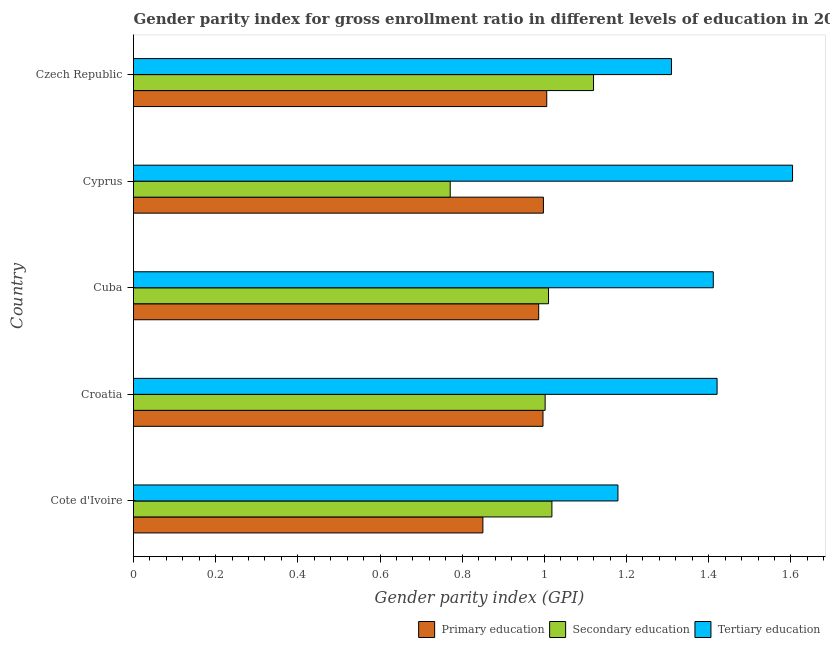How many different coloured bars are there?
Your answer should be compact. 3. Are the number of bars per tick equal to the number of legend labels?
Provide a succinct answer. Yes. How many bars are there on the 2nd tick from the top?
Your answer should be compact. 3. What is the label of the 1st group of bars from the top?
Give a very brief answer. Czech Republic. In how many cases, is the number of bars for a given country not equal to the number of legend labels?
Your response must be concise. 0. What is the gender parity index in secondary education in Croatia?
Offer a very short reply. 1. Across all countries, what is the maximum gender parity index in secondary education?
Offer a very short reply. 1.12. Across all countries, what is the minimum gender parity index in primary education?
Your answer should be very brief. 0.85. In which country was the gender parity index in tertiary education maximum?
Your answer should be very brief. Cyprus. In which country was the gender parity index in secondary education minimum?
Ensure brevity in your answer.  Cyprus. What is the total gender parity index in tertiary education in the graph?
Offer a terse response. 6.92. What is the difference between the gender parity index in primary education in Cuba and that in Czech Republic?
Provide a succinct answer. -0.02. What is the difference between the gender parity index in tertiary education in Cyprus and the gender parity index in primary education in Cuba?
Keep it short and to the point. 0.62. What is the average gender parity index in tertiary education per country?
Provide a succinct answer. 1.39. What is the difference between the gender parity index in secondary education and gender parity index in tertiary education in Cote d'Ivoire?
Provide a short and direct response. -0.16. What is the ratio of the gender parity index in tertiary education in Croatia to that in Czech Republic?
Offer a very short reply. 1.08. Is the gender parity index in secondary education in Cote d'Ivoire less than that in Cuba?
Offer a very short reply. No. Is the difference between the gender parity index in secondary education in Cote d'Ivoire and Croatia greater than the difference between the gender parity index in primary education in Cote d'Ivoire and Croatia?
Ensure brevity in your answer.  Yes. What is the difference between the highest and the second highest gender parity index in secondary education?
Your response must be concise. 0.1. What is the difference between the highest and the lowest gender parity index in primary education?
Give a very brief answer. 0.16. In how many countries, is the gender parity index in tertiary education greater than the average gender parity index in tertiary education taken over all countries?
Your response must be concise. 3. What does the 2nd bar from the top in Cuba represents?
Provide a short and direct response. Secondary education. What does the 3rd bar from the bottom in Cuba represents?
Ensure brevity in your answer.  Tertiary education. How many bars are there?
Provide a succinct answer. 15. What is the difference between two consecutive major ticks on the X-axis?
Your answer should be compact. 0.2. Does the graph contain any zero values?
Give a very brief answer. No. Where does the legend appear in the graph?
Your response must be concise. Bottom right. How many legend labels are there?
Provide a succinct answer. 3. What is the title of the graph?
Ensure brevity in your answer.  Gender parity index for gross enrollment ratio in different levels of education in 2012. Does "Consumption Tax" appear as one of the legend labels in the graph?
Give a very brief answer. No. What is the label or title of the X-axis?
Your answer should be very brief. Gender parity index (GPI). What is the Gender parity index (GPI) in Primary education in Cote d'Ivoire?
Keep it short and to the point. 0.85. What is the Gender parity index (GPI) in Secondary education in Cote d'Ivoire?
Your answer should be very brief. 1.02. What is the Gender parity index (GPI) in Tertiary education in Cote d'Ivoire?
Make the answer very short. 1.18. What is the Gender parity index (GPI) in Primary education in Croatia?
Your answer should be compact. 1. What is the Gender parity index (GPI) of Secondary education in Croatia?
Give a very brief answer. 1. What is the Gender parity index (GPI) of Tertiary education in Croatia?
Provide a short and direct response. 1.42. What is the Gender parity index (GPI) of Primary education in Cuba?
Provide a succinct answer. 0.99. What is the Gender parity index (GPI) in Secondary education in Cuba?
Provide a short and direct response. 1.01. What is the Gender parity index (GPI) of Tertiary education in Cuba?
Your answer should be very brief. 1.41. What is the Gender parity index (GPI) in Primary education in Cyprus?
Your response must be concise. 1. What is the Gender parity index (GPI) of Secondary education in Cyprus?
Offer a very short reply. 0.77. What is the Gender parity index (GPI) of Tertiary education in Cyprus?
Make the answer very short. 1.6. What is the Gender parity index (GPI) in Primary education in Czech Republic?
Keep it short and to the point. 1.01. What is the Gender parity index (GPI) of Secondary education in Czech Republic?
Your answer should be very brief. 1.12. What is the Gender parity index (GPI) of Tertiary education in Czech Republic?
Provide a succinct answer. 1.31. Across all countries, what is the maximum Gender parity index (GPI) in Primary education?
Offer a terse response. 1.01. Across all countries, what is the maximum Gender parity index (GPI) of Secondary education?
Provide a succinct answer. 1.12. Across all countries, what is the maximum Gender parity index (GPI) of Tertiary education?
Provide a short and direct response. 1.6. Across all countries, what is the minimum Gender parity index (GPI) in Primary education?
Ensure brevity in your answer.  0.85. Across all countries, what is the minimum Gender parity index (GPI) of Secondary education?
Provide a succinct answer. 0.77. Across all countries, what is the minimum Gender parity index (GPI) of Tertiary education?
Your response must be concise. 1.18. What is the total Gender parity index (GPI) of Primary education in the graph?
Your answer should be compact. 4.84. What is the total Gender parity index (GPI) of Secondary education in the graph?
Provide a short and direct response. 4.92. What is the total Gender parity index (GPI) of Tertiary education in the graph?
Give a very brief answer. 6.92. What is the difference between the Gender parity index (GPI) in Primary education in Cote d'Ivoire and that in Croatia?
Provide a succinct answer. -0.15. What is the difference between the Gender parity index (GPI) of Secondary education in Cote d'Ivoire and that in Croatia?
Your answer should be compact. 0.02. What is the difference between the Gender parity index (GPI) of Tertiary education in Cote d'Ivoire and that in Croatia?
Give a very brief answer. -0.24. What is the difference between the Gender parity index (GPI) of Primary education in Cote d'Ivoire and that in Cuba?
Offer a very short reply. -0.14. What is the difference between the Gender parity index (GPI) in Secondary education in Cote d'Ivoire and that in Cuba?
Provide a succinct answer. 0.01. What is the difference between the Gender parity index (GPI) of Tertiary education in Cote d'Ivoire and that in Cuba?
Your answer should be compact. -0.23. What is the difference between the Gender parity index (GPI) of Primary education in Cote d'Ivoire and that in Cyprus?
Your answer should be very brief. -0.15. What is the difference between the Gender parity index (GPI) of Secondary education in Cote d'Ivoire and that in Cyprus?
Keep it short and to the point. 0.25. What is the difference between the Gender parity index (GPI) in Tertiary education in Cote d'Ivoire and that in Cyprus?
Ensure brevity in your answer.  -0.42. What is the difference between the Gender parity index (GPI) in Primary education in Cote d'Ivoire and that in Czech Republic?
Offer a very short reply. -0.16. What is the difference between the Gender parity index (GPI) in Secondary education in Cote d'Ivoire and that in Czech Republic?
Ensure brevity in your answer.  -0.1. What is the difference between the Gender parity index (GPI) of Tertiary education in Cote d'Ivoire and that in Czech Republic?
Provide a succinct answer. -0.13. What is the difference between the Gender parity index (GPI) in Primary education in Croatia and that in Cuba?
Provide a short and direct response. 0.01. What is the difference between the Gender parity index (GPI) in Secondary education in Croatia and that in Cuba?
Ensure brevity in your answer.  -0.01. What is the difference between the Gender parity index (GPI) of Tertiary education in Croatia and that in Cuba?
Ensure brevity in your answer.  0.01. What is the difference between the Gender parity index (GPI) of Primary education in Croatia and that in Cyprus?
Provide a short and direct response. -0. What is the difference between the Gender parity index (GPI) in Secondary education in Croatia and that in Cyprus?
Offer a very short reply. 0.23. What is the difference between the Gender parity index (GPI) in Tertiary education in Croatia and that in Cyprus?
Offer a terse response. -0.18. What is the difference between the Gender parity index (GPI) of Primary education in Croatia and that in Czech Republic?
Provide a succinct answer. -0.01. What is the difference between the Gender parity index (GPI) in Secondary education in Croatia and that in Czech Republic?
Your answer should be compact. -0.12. What is the difference between the Gender parity index (GPI) in Tertiary education in Croatia and that in Czech Republic?
Your answer should be compact. 0.11. What is the difference between the Gender parity index (GPI) in Primary education in Cuba and that in Cyprus?
Make the answer very short. -0.01. What is the difference between the Gender parity index (GPI) of Secondary education in Cuba and that in Cyprus?
Provide a short and direct response. 0.24. What is the difference between the Gender parity index (GPI) of Tertiary education in Cuba and that in Cyprus?
Provide a succinct answer. -0.19. What is the difference between the Gender parity index (GPI) of Primary education in Cuba and that in Czech Republic?
Give a very brief answer. -0.02. What is the difference between the Gender parity index (GPI) of Secondary education in Cuba and that in Czech Republic?
Your answer should be compact. -0.11. What is the difference between the Gender parity index (GPI) in Tertiary education in Cuba and that in Czech Republic?
Give a very brief answer. 0.1. What is the difference between the Gender parity index (GPI) of Primary education in Cyprus and that in Czech Republic?
Offer a terse response. -0.01. What is the difference between the Gender parity index (GPI) of Secondary education in Cyprus and that in Czech Republic?
Your answer should be compact. -0.35. What is the difference between the Gender parity index (GPI) in Tertiary education in Cyprus and that in Czech Republic?
Keep it short and to the point. 0.29. What is the difference between the Gender parity index (GPI) in Primary education in Cote d'Ivoire and the Gender parity index (GPI) in Secondary education in Croatia?
Keep it short and to the point. -0.15. What is the difference between the Gender parity index (GPI) of Primary education in Cote d'Ivoire and the Gender parity index (GPI) of Tertiary education in Croatia?
Offer a terse response. -0.57. What is the difference between the Gender parity index (GPI) of Secondary education in Cote d'Ivoire and the Gender parity index (GPI) of Tertiary education in Croatia?
Your answer should be compact. -0.4. What is the difference between the Gender parity index (GPI) of Primary education in Cote d'Ivoire and the Gender parity index (GPI) of Secondary education in Cuba?
Provide a succinct answer. -0.16. What is the difference between the Gender parity index (GPI) in Primary education in Cote d'Ivoire and the Gender parity index (GPI) in Tertiary education in Cuba?
Provide a short and direct response. -0.56. What is the difference between the Gender parity index (GPI) in Secondary education in Cote d'Ivoire and the Gender parity index (GPI) in Tertiary education in Cuba?
Ensure brevity in your answer.  -0.39. What is the difference between the Gender parity index (GPI) in Primary education in Cote d'Ivoire and the Gender parity index (GPI) in Secondary education in Cyprus?
Offer a terse response. 0.08. What is the difference between the Gender parity index (GPI) of Primary education in Cote d'Ivoire and the Gender parity index (GPI) of Tertiary education in Cyprus?
Provide a short and direct response. -0.75. What is the difference between the Gender parity index (GPI) in Secondary education in Cote d'Ivoire and the Gender parity index (GPI) in Tertiary education in Cyprus?
Your answer should be compact. -0.59. What is the difference between the Gender parity index (GPI) of Primary education in Cote d'Ivoire and the Gender parity index (GPI) of Secondary education in Czech Republic?
Your answer should be compact. -0.27. What is the difference between the Gender parity index (GPI) in Primary education in Cote d'Ivoire and the Gender parity index (GPI) in Tertiary education in Czech Republic?
Keep it short and to the point. -0.46. What is the difference between the Gender parity index (GPI) in Secondary education in Cote d'Ivoire and the Gender parity index (GPI) in Tertiary education in Czech Republic?
Give a very brief answer. -0.29. What is the difference between the Gender parity index (GPI) of Primary education in Croatia and the Gender parity index (GPI) of Secondary education in Cuba?
Provide a short and direct response. -0.01. What is the difference between the Gender parity index (GPI) in Primary education in Croatia and the Gender parity index (GPI) in Tertiary education in Cuba?
Your answer should be very brief. -0.41. What is the difference between the Gender parity index (GPI) in Secondary education in Croatia and the Gender parity index (GPI) in Tertiary education in Cuba?
Make the answer very short. -0.41. What is the difference between the Gender parity index (GPI) of Primary education in Croatia and the Gender parity index (GPI) of Secondary education in Cyprus?
Make the answer very short. 0.23. What is the difference between the Gender parity index (GPI) in Primary education in Croatia and the Gender parity index (GPI) in Tertiary education in Cyprus?
Offer a very short reply. -0.61. What is the difference between the Gender parity index (GPI) of Secondary education in Croatia and the Gender parity index (GPI) of Tertiary education in Cyprus?
Provide a succinct answer. -0.6. What is the difference between the Gender parity index (GPI) in Primary education in Croatia and the Gender parity index (GPI) in Secondary education in Czech Republic?
Offer a very short reply. -0.12. What is the difference between the Gender parity index (GPI) of Primary education in Croatia and the Gender parity index (GPI) of Tertiary education in Czech Republic?
Give a very brief answer. -0.31. What is the difference between the Gender parity index (GPI) of Secondary education in Croatia and the Gender parity index (GPI) of Tertiary education in Czech Republic?
Make the answer very short. -0.31. What is the difference between the Gender parity index (GPI) of Primary education in Cuba and the Gender parity index (GPI) of Secondary education in Cyprus?
Give a very brief answer. 0.22. What is the difference between the Gender parity index (GPI) in Primary education in Cuba and the Gender parity index (GPI) in Tertiary education in Cyprus?
Give a very brief answer. -0.62. What is the difference between the Gender parity index (GPI) of Secondary education in Cuba and the Gender parity index (GPI) of Tertiary education in Cyprus?
Make the answer very short. -0.59. What is the difference between the Gender parity index (GPI) of Primary education in Cuba and the Gender parity index (GPI) of Secondary education in Czech Republic?
Offer a very short reply. -0.13. What is the difference between the Gender parity index (GPI) in Primary education in Cuba and the Gender parity index (GPI) in Tertiary education in Czech Republic?
Your response must be concise. -0.32. What is the difference between the Gender parity index (GPI) of Secondary education in Cuba and the Gender parity index (GPI) of Tertiary education in Czech Republic?
Offer a terse response. -0.3. What is the difference between the Gender parity index (GPI) of Primary education in Cyprus and the Gender parity index (GPI) of Secondary education in Czech Republic?
Offer a terse response. -0.12. What is the difference between the Gender parity index (GPI) of Primary education in Cyprus and the Gender parity index (GPI) of Tertiary education in Czech Republic?
Make the answer very short. -0.31. What is the difference between the Gender parity index (GPI) in Secondary education in Cyprus and the Gender parity index (GPI) in Tertiary education in Czech Republic?
Ensure brevity in your answer.  -0.54. What is the average Gender parity index (GPI) in Primary education per country?
Give a very brief answer. 0.97. What is the average Gender parity index (GPI) in Secondary education per country?
Provide a succinct answer. 0.98. What is the average Gender parity index (GPI) of Tertiary education per country?
Your response must be concise. 1.38. What is the difference between the Gender parity index (GPI) in Primary education and Gender parity index (GPI) in Secondary education in Cote d'Ivoire?
Ensure brevity in your answer.  -0.17. What is the difference between the Gender parity index (GPI) of Primary education and Gender parity index (GPI) of Tertiary education in Cote d'Ivoire?
Provide a short and direct response. -0.33. What is the difference between the Gender parity index (GPI) of Secondary education and Gender parity index (GPI) of Tertiary education in Cote d'Ivoire?
Your answer should be compact. -0.16. What is the difference between the Gender parity index (GPI) in Primary education and Gender parity index (GPI) in Secondary education in Croatia?
Give a very brief answer. -0.01. What is the difference between the Gender parity index (GPI) in Primary education and Gender parity index (GPI) in Tertiary education in Croatia?
Your answer should be compact. -0.42. What is the difference between the Gender parity index (GPI) of Secondary education and Gender parity index (GPI) of Tertiary education in Croatia?
Give a very brief answer. -0.42. What is the difference between the Gender parity index (GPI) of Primary education and Gender parity index (GPI) of Secondary education in Cuba?
Ensure brevity in your answer.  -0.02. What is the difference between the Gender parity index (GPI) of Primary education and Gender parity index (GPI) of Tertiary education in Cuba?
Provide a short and direct response. -0.42. What is the difference between the Gender parity index (GPI) in Secondary education and Gender parity index (GPI) in Tertiary education in Cuba?
Give a very brief answer. -0.4. What is the difference between the Gender parity index (GPI) in Primary education and Gender parity index (GPI) in Secondary education in Cyprus?
Offer a very short reply. 0.23. What is the difference between the Gender parity index (GPI) in Primary education and Gender parity index (GPI) in Tertiary education in Cyprus?
Keep it short and to the point. -0.61. What is the difference between the Gender parity index (GPI) of Secondary education and Gender parity index (GPI) of Tertiary education in Cyprus?
Keep it short and to the point. -0.83. What is the difference between the Gender parity index (GPI) of Primary education and Gender parity index (GPI) of Secondary education in Czech Republic?
Give a very brief answer. -0.11. What is the difference between the Gender parity index (GPI) of Primary education and Gender parity index (GPI) of Tertiary education in Czech Republic?
Provide a succinct answer. -0.3. What is the difference between the Gender parity index (GPI) in Secondary education and Gender parity index (GPI) in Tertiary education in Czech Republic?
Keep it short and to the point. -0.19. What is the ratio of the Gender parity index (GPI) in Primary education in Cote d'Ivoire to that in Croatia?
Give a very brief answer. 0.85. What is the ratio of the Gender parity index (GPI) in Secondary education in Cote d'Ivoire to that in Croatia?
Keep it short and to the point. 1.02. What is the ratio of the Gender parity index (GPI) of Tertiary education in Cote d'Ivoire to that in Croatia?
Give a very brief answer. 0.83. What is the ratio of the Gender parity index (GPI) in Primary education in Cote d'Ivoire to that in Cuba?
Your response must be concise. 0.86. What is the ratio of the Gender parity index (GPI) of Tertiary education in Cote d'Ivoire to that in Cuba?
Offer a very short reply. 0.84. What is the ratio of the Gender parity index (GPI) in Primary education in Cote d'Ivoire to that in Cyprus?
Give a very brief answer. 0.85. What is the ratio of the Gender parity index (GPI) of Secondary education in Cote d'Ivoire to that in Cyprus?
Provide a succinct answer. 1.32. What is the ratio of the Gender parity index (GPI) of Tertiary education in Cote d'Ivoire to that in Cyprus?
Offer a very short reply. 0.74. What is the ratio of the Gender parity index (GPI) in Primary education in Cote d'Ivoire to that in Czech Republic?
Offer a very short reply. 0.85. What is the ratio of the Gender parity index (GPI) of Secondary education in Cote d'Ivoire to that in Czech Republic?
Your response must be concise. 0.91. What is the ratio of the Gender parity index (GPI) of Tertiary education in Cote d'Ivoire to that in Czech Republic?
Provide a succinct answer. 0.9. What is the ratio of the Gender parity index (GPI) in Primary education in Croatia to that in Cuba?
Provide a succinct answer. 1.01. What is the ratio of the Gender parity index (GPI) in Tertiary education in Croatia to that in Cuba?
Make the answer very short. 1.01. What is the ratio of the Gender parity index (GPI) of Secondary education in Croatia to that in Cyprus?
Offer a very short reply. 1.3. What is the ratio of the Gender parity index (GPI) of Tertiary education in Croatia to that in Cyprus?
Provide a succinct answer. 0.89. What is the ratio of the Gender parity index (GPI) in Primary education in Croatia to that in Czech Republic?
Give a very brief answer. 0.99. What is the ratio of the Gender parity index (GPI) of Secondary education in Croatia to that in Czech Republic?
Offer a very short reply. 0.89. What is the ratio of the Gender parity index (GPI) of Tertiary education in Croatia to that in Czech Republic?
Ensure brevity in your answer.  1.08. What is the ratio of the Gender parity index (GPI) of Primary education in Cuba to that in Cyprus?
Keep it short and to the point. 0.99. What is the ratio of the Gender parity index (GPI) in Secondary education in Cuba to that in Cyprus?
Ensure brevity in your answer.  1.31. What is the ratio of the Gender parity index (GPI) of Tertiary education in Cuba to that in Cyprus?
Ensure brevity in your answer.  0.88. What is the ratio of the Gender parity index (GPI) of Primary education in Cuba to that in Czech Republic?
Offer a very short reply. 0.98. What is the ratio of the Gender parity index (GPI) in Secondary education in Cuba to that in Czech Republic?
Your response must be concise. 0.9. What is the ratio of the Gender parity index (GPI) in Tertiary education in Cuba to that in Czech Republic?
Make the answer very short. 1.08. What is the ratio of the Gender parity index (GPI) in Primary education in Cyprus to that in Czech Republic?
Make the answer very short. 0.99. What is the ratio of the Gender parity index (GPI) of Secondary education in Cyprus to that in Czech Republic?
Your answer should be very brief. 0.69. What is the ratio of the Gender parity index (GPI) in Tertiary education in Cyprus to that in Czech Republic?
Make the answer very short. 1.23. What is the difference between the highest and the second highest Gender parity index (GPI) of Primary education?
Offer a very short reply. 0.01. What is the difference between the highest and the second highest Gender parity index (GPI) in Secondary education?
Give a very brief answer. 0.1. What is the difference between the highest and the second highest Gender parity index (GPI) in Tertiary education?
Keep it short and to the point. 0.18. What is the difference between the highest and the lowest Gender parity index (GPI) in Primary education?
Provide a short and direct response. 0.16. What is the difference between the highest and the lowest Gender parity index (GPI) of Secondary education?
Keep it short and to the point. 0.35. What is the difference between the highest and the lowest Gender parity index (GPI) of Tertiary education?
Offer a terse response. 0.42. 